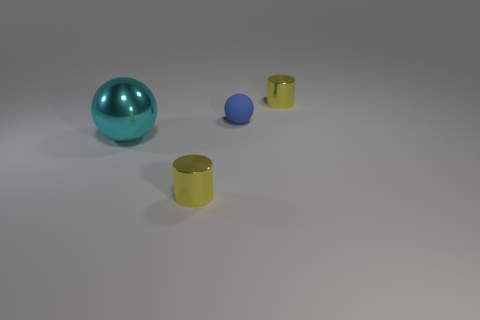There is a yellow object behind the tiny rubber ball behind the big thing; what is its shape?
Give a very brief answer. Cylinder. How many gray objects are either small metal cubes or tiny things?
Keep it short and to the point. 0. What color is the tiny rubber object?
Your answer should be very brief. Blue. Does the blue thing have the same size as the cyan metallic sphere?
Your answer should be compact. No. Are there any other things that have the same shape as the small blue thing?
Keep it short and to the point. Yes. Is the cyan sphere made of the same material as the cylinder behind the big cyan metal ball?
Your answer should be very brief. Yes. Does the small metal cylinder in front of the cyan object have the same color as the small ball?
Give a very brief answer. No. What number of things are left of the blue object and to the right of the big metallic object?
Your answer should be very brief. 1. How many other objects are there of the same material as the small blue sphere?
Your answer should be compact. 0. Are the yellow object behind the cyan metal ball and the large cyan ball made of the same material?
Offer a terse response. Yes. 